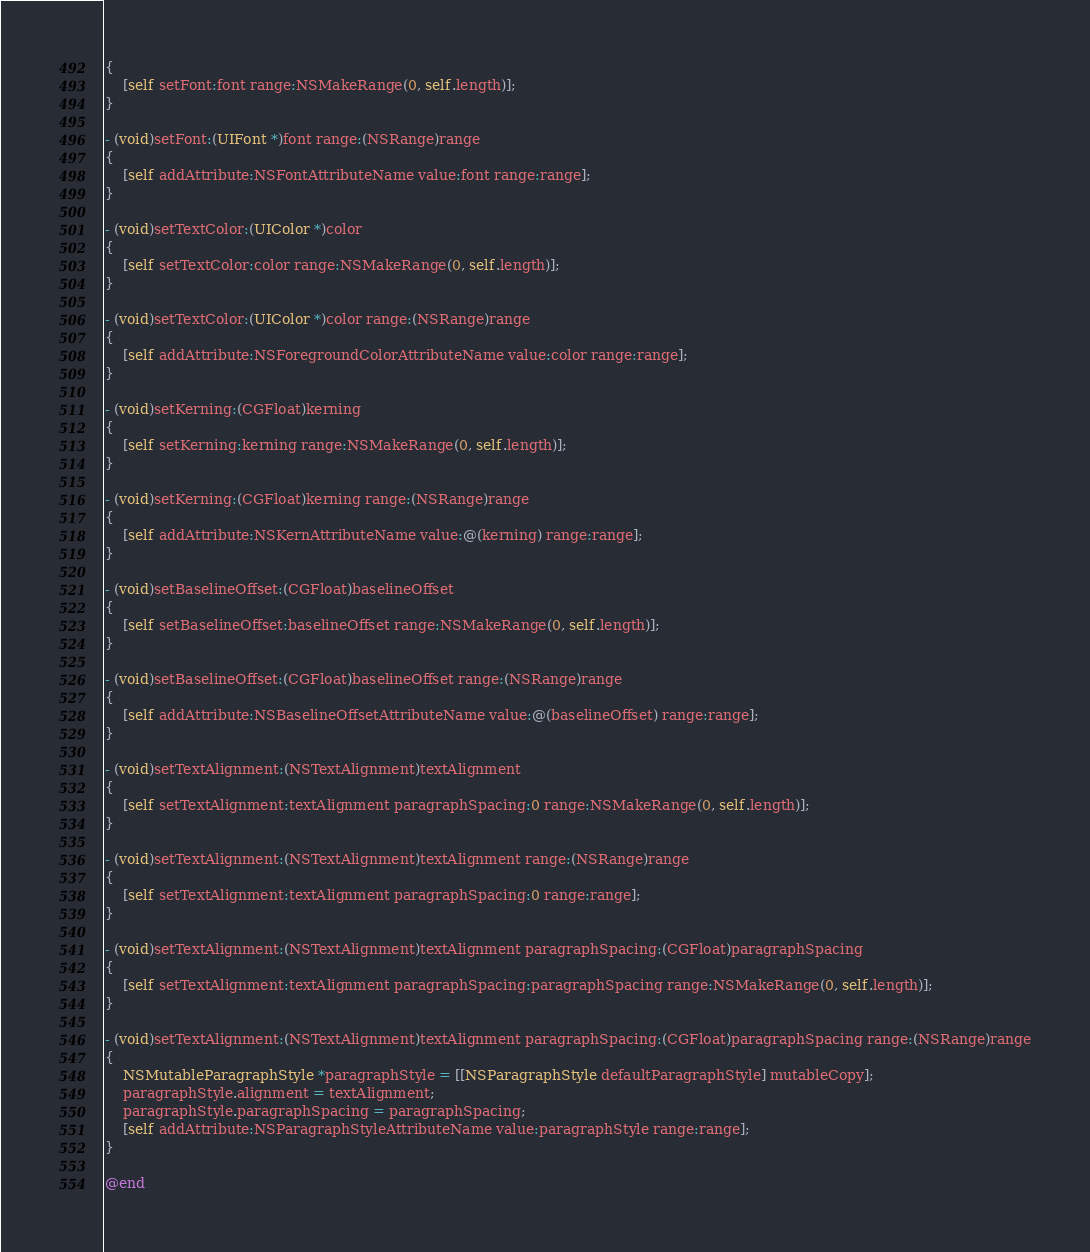Convert code to text. <code><loc_0><loc_0><loc_500><loc_500><_ObjectiveC_>{
    [self setFont:font range:NSMakeRange(0, self.length)];
}

- (void)setFont:(UIFont *)font range:(NSRange)range
{
    [self addAttribute:NSFontAttributeName value:font range:range];
}

- (void)setTextColor:(UIColor *)color
{
    [self setTextColor:color range:NSMakeRange(0, self.length)];
}

- (void)setTextColor:(UIColor *)color range:(NSRange)range
{
    [self addAttribute:NSForegroundColorAttributeName value:color range:range];
}

- (void)setKerning:(CGFloat)kerning
{
    [self setKerning:kerning range:NSMakeRange(0, self.length)];
}

- (void)setKerning:(CGFloat)kerning range:(NSRange)range
{
    [self addAttribute:NSKernAttributeName value:@(kerning) range:range];
}

- (void)setBaselineOffset:(CGFloat)baselineOffset
{
    [self setBaselineOffset:baselineOffset range:NSMakeRange(0, self.length)];
}

- (void)setBaselineOffset:(CGFloat)baselineOffset range:(NSRange)range
{
    [self addAttribute:NSBaselineOffsetAttributeName value:@(baselineOffset) range:range];
}

- (void)setTextAlignment:(NSTextAlignment)textAlignment
{
    [self setTextAlignment:textAlignment paragraphSpacing:0 range:NSMakeRange(0, self.length)];
}

- (void)setTextAlignment:(NSTextAlignment)textAlignment range:(NSRange)range
{
    [self setTextAlignment:textAlignment paragraphSpacing:0 range:range];
}

- (void)setTextAlignment:(NSTextAlignment)textAlignment paragraphSpacing:(CGFloat)paragraphSpacing
{
    [self setTextAlignment:textAlignment paragraphSpacing:paragraphSpacing range:NSMakeRange(0, self.length)];
}

- (void)setTextAlignment:(NSTextAlignment)textAlignment paragraphSpacing:(CGFloat)paragraphSpacing range:(NSRange)range
{
    NSMutableParagraphStyle *paragraphStyle = [[NSParagraphStyle defaultParagraphStyle] mutableCopy];
    paragraphStyle.alignment = textAlignment;
    paragraphStyle.paragraphSpacing = paragraphSpacing;
    [self addAttribute:NSParagraphStyleAttributeName value:paragraphStyle range:range];
}

@end
</code> 